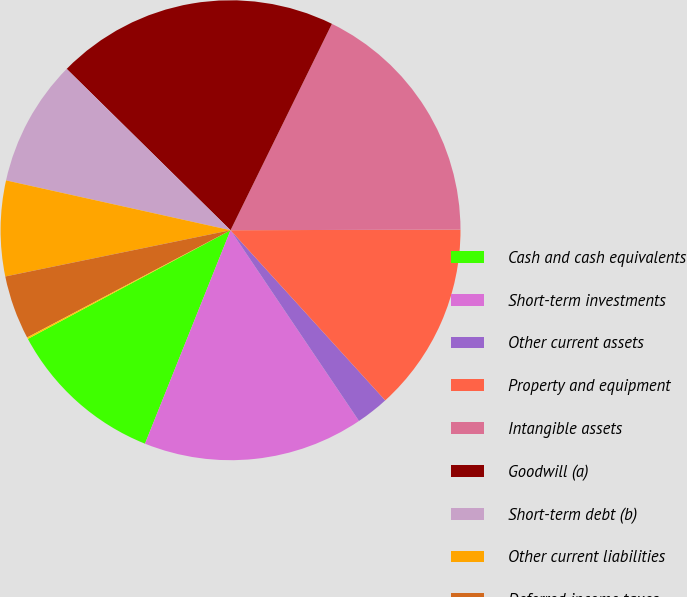<chart> <loc_0><loc_0><loc_500><loc_500><pie_chart><fcel>Cash and cash equivalents<fcel>Short-term investments<fcel>Other current assets<fcel>Property and equipment<fcel>Intangible assets<fcel>Goodwill (a)<fcel>Short-term debt (b)<fcel>Other current liabilities<fcel>Deferred income taxes<fcel>Other<nl><fcel>11.1%<fcel>15.5%<fcel>2.31%<fcel>13.3%<fcel>17.69%<fcel>19.89%<fcel>8.9%<fcel>6.7%<fcel>4.5%<fcel>0.11%<nl></chart> 